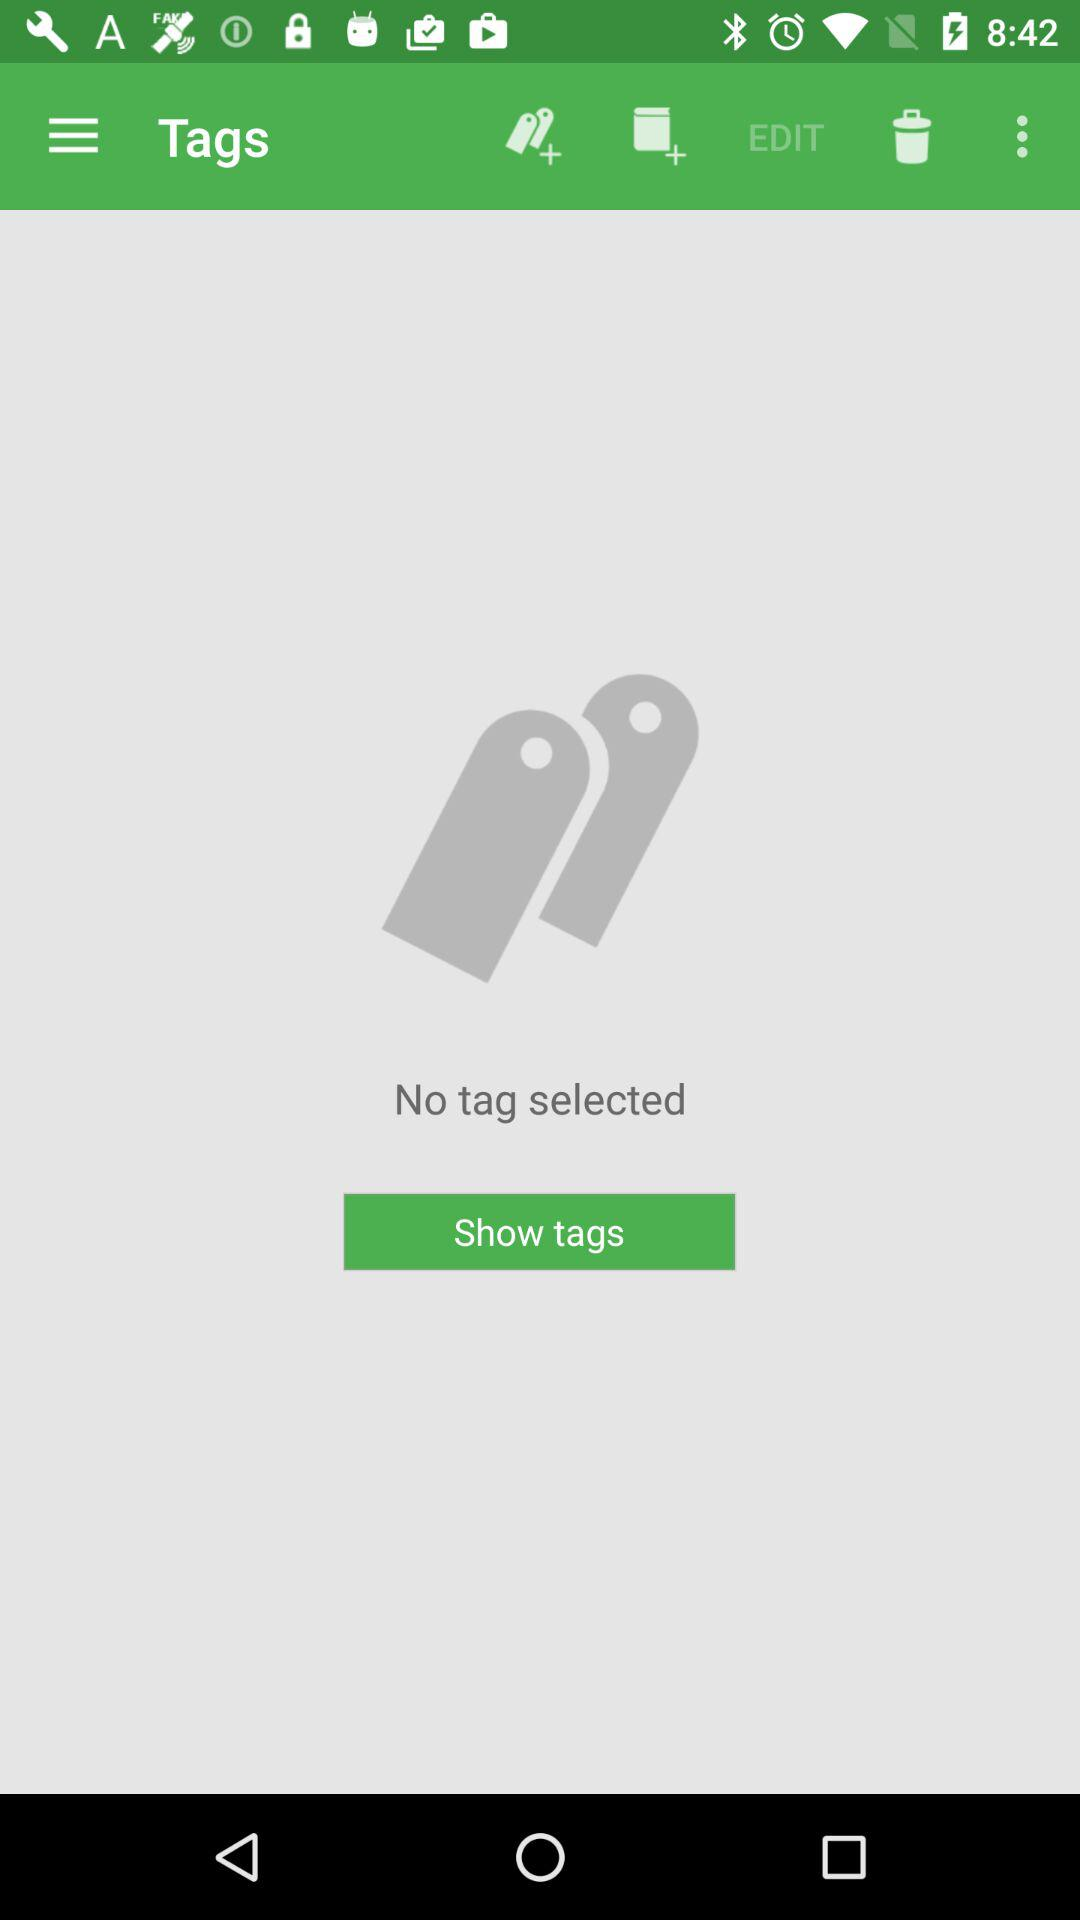Are there any tags selected? There is no tag selected. 